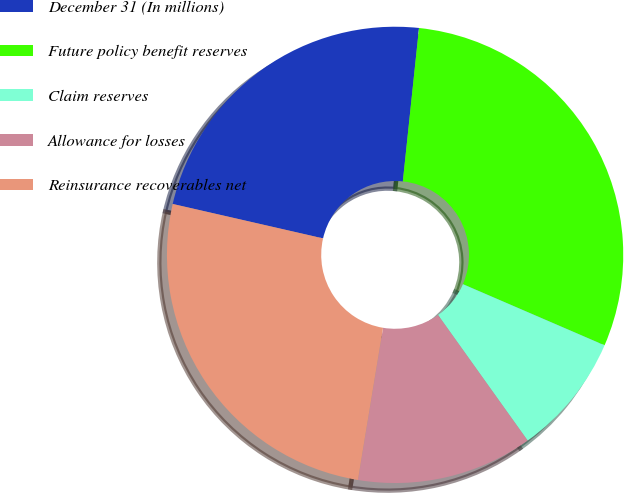<chart> <loc_0><loc_0><loc_500><loc_500><pie_chart><fcel>December 31 (In millions)<fcel>Future policy benefit reserves<fcel>Claim reserves<fcel>Allowance for losses<fcel>Reinsurance recoverables net<nl><fcel>23.09%<fcel>29.81%<fcel>8.65%<fcel>12.47%<fcel>25.98%<nl></chart> 